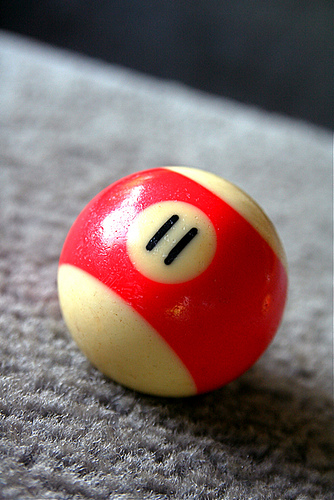<image>
Is there a surface behind the ball? Yes. From this viewpoint, the surface is positioned behind the ball, with the ball partially or fully occluding the surface. 